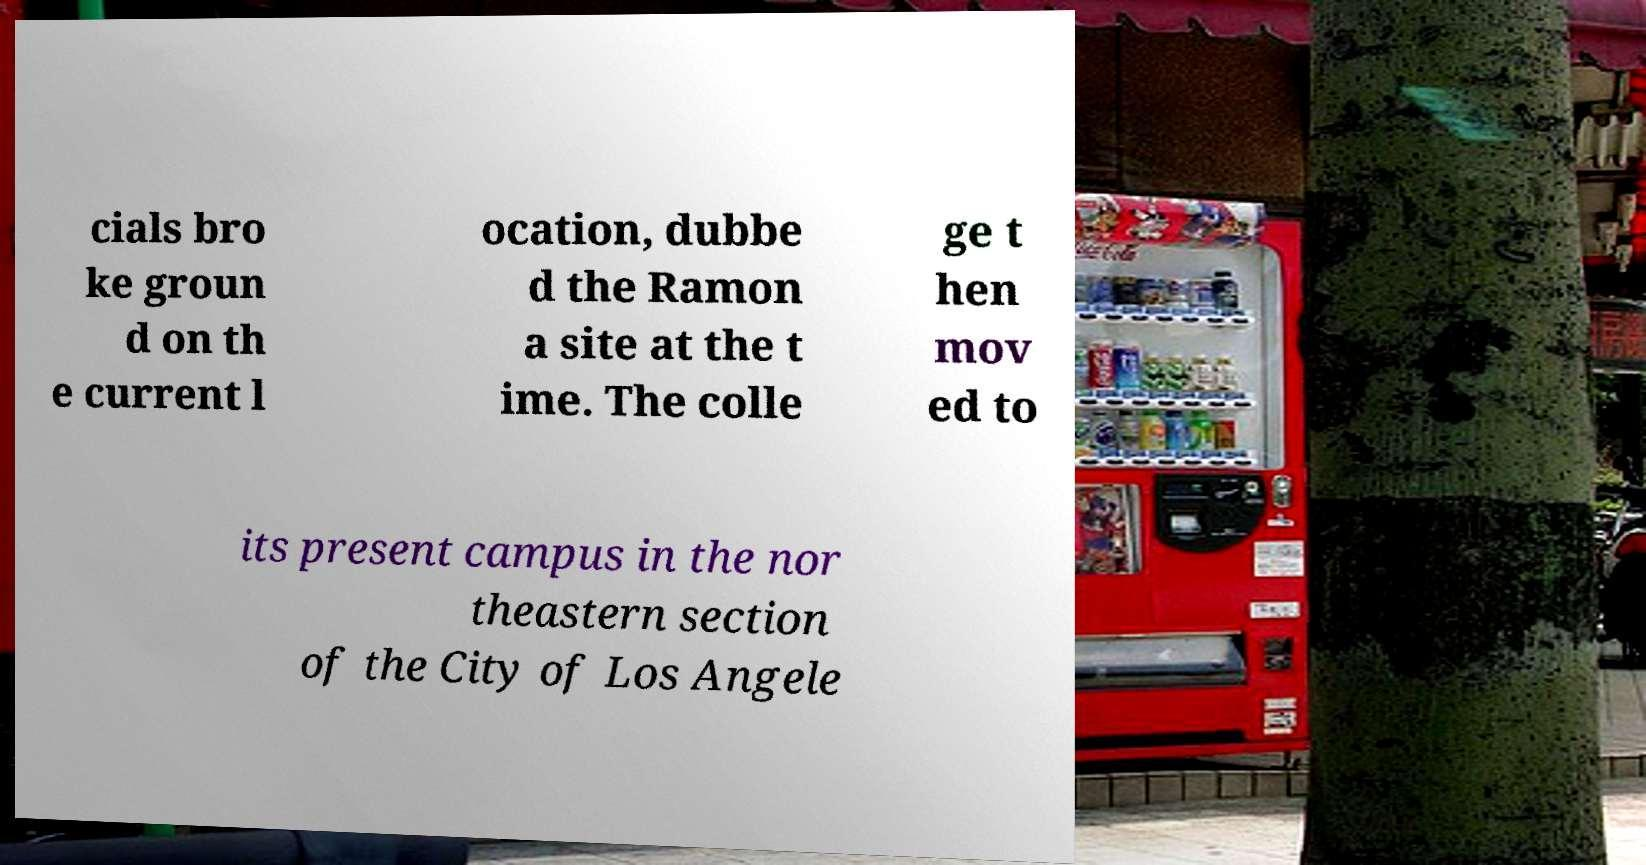There's text embedded in this image that I need extracted. Can you transcribe it verbatim? cials bro ke groun d on th e current l ocation, dubbe d the Ramon a site at the t ime. The colle ge t hen mov ed to its present campus in the nor theastern section of the City of Los Angele 